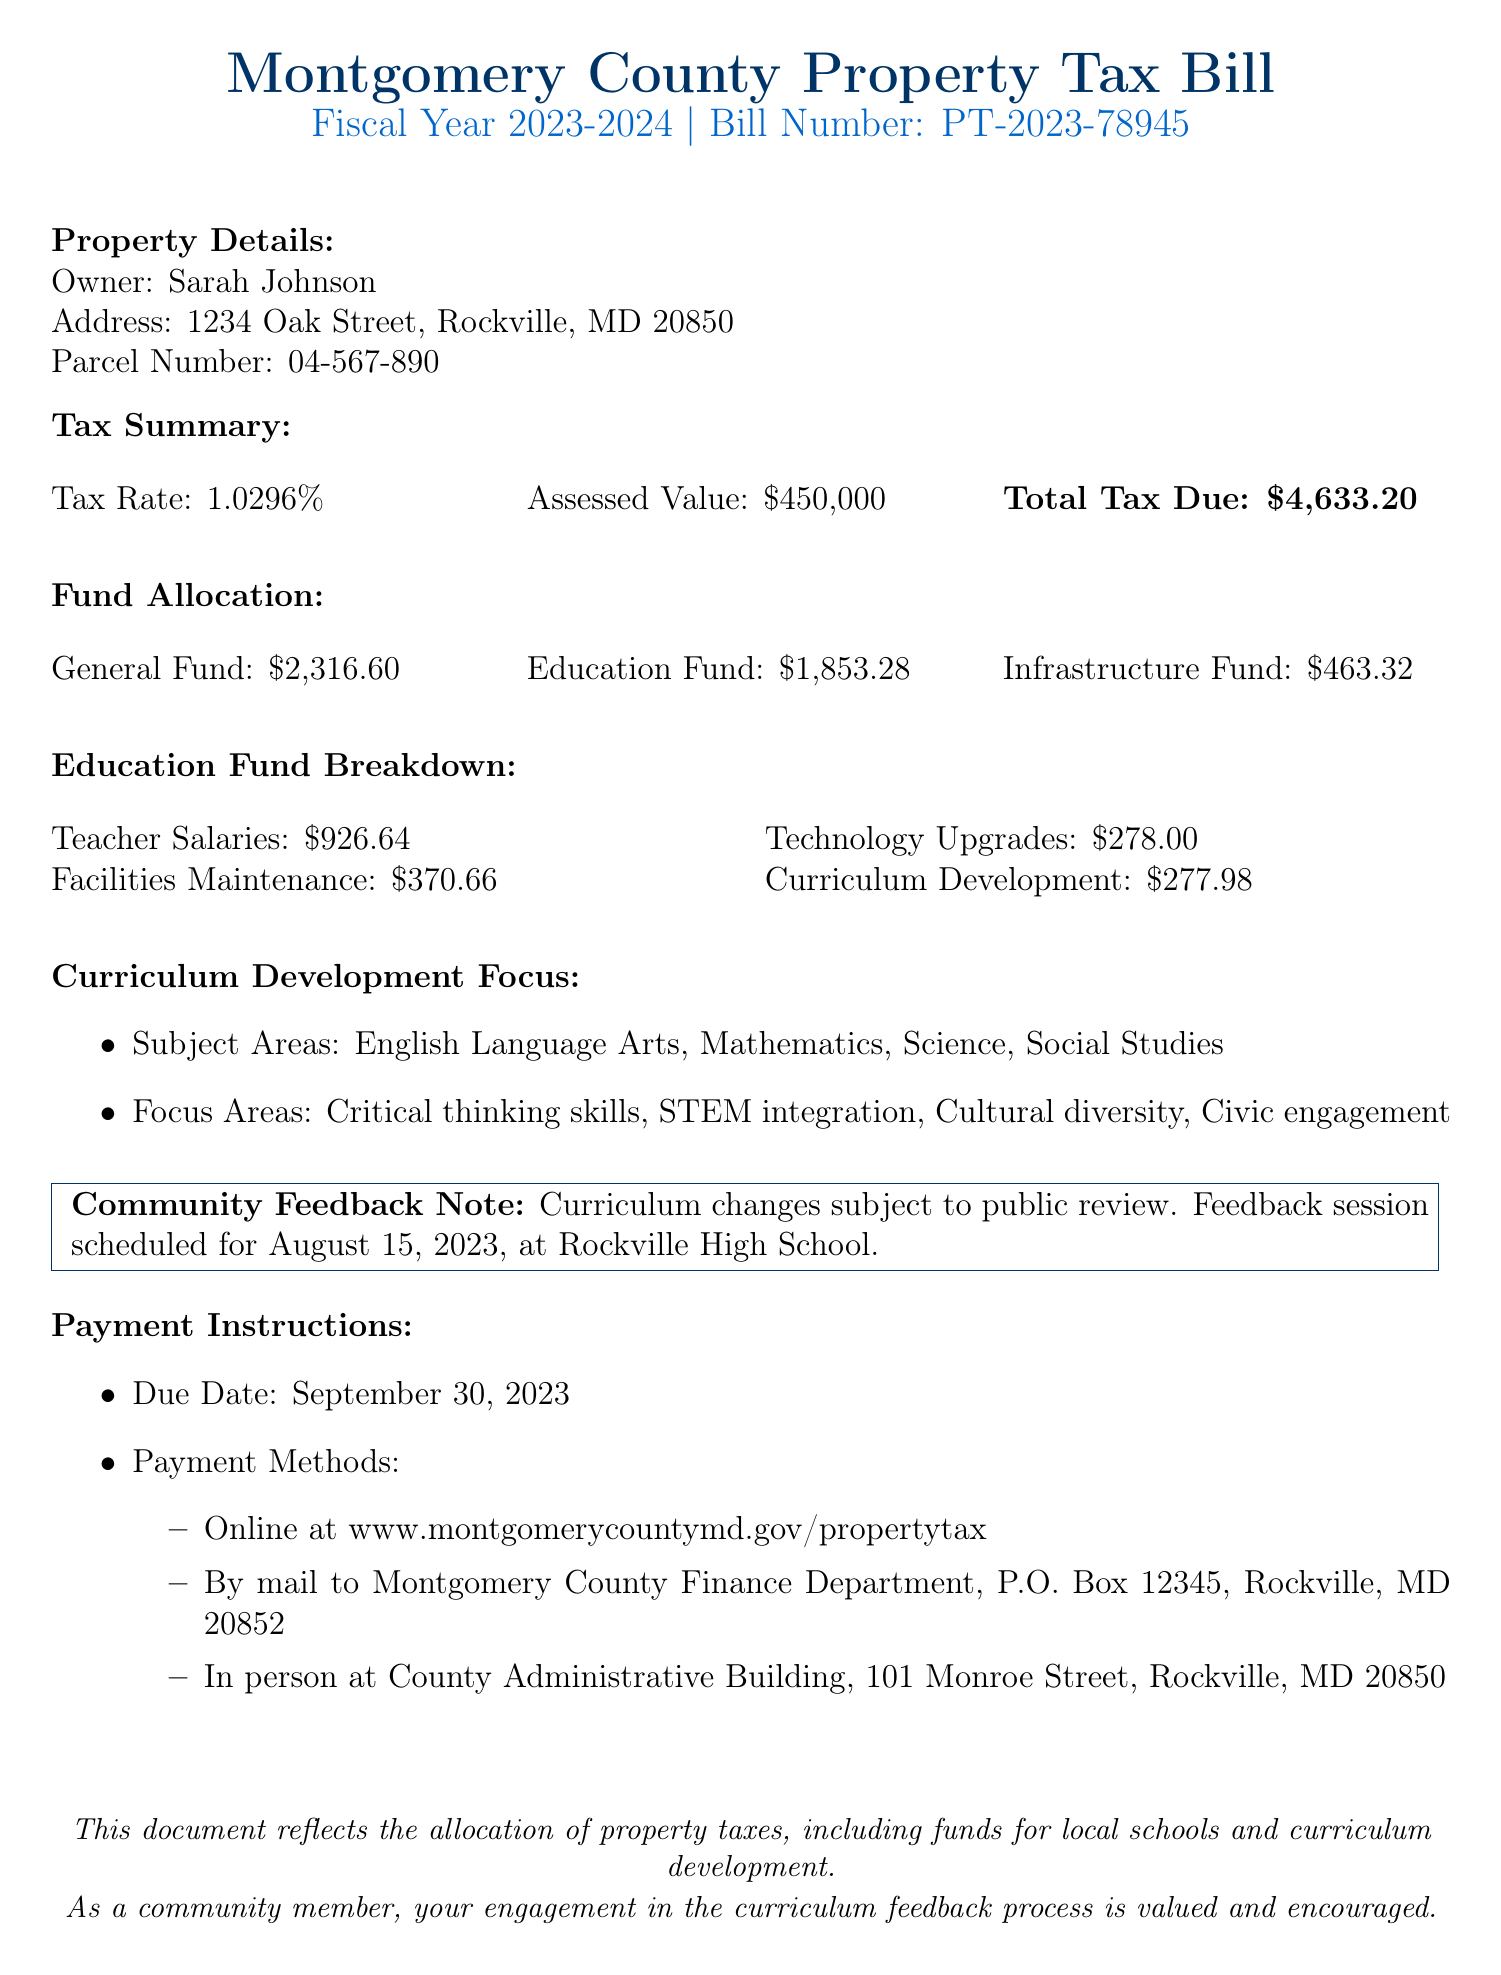what is the property tax rate? The property tax rate is directly stated in the document's tax summary section.
Answer: 1.0296% what is the total tax due? The total tax due is calculated and mentioned in the tax summary section.
Answer: $4,633.20 how much is allocated to the Education Fund? The amount allocated to the Education Fund is detailed in the fund allocation section of the document.
Answer: $1,853.28 what are the main focus areas for curriculum development? The focus areas for curriculum development are listed under the curriculum development focus section.
Answer: Critical thinking skills, STEM integration, Cultural diversity, Civic engagement when is the community feedback session scheduled? The date of the community feedback session is noted in the community feedback note section.
Answer: August 15, 2023 what is the breakdown of funds allocated for Teacher Salaries? The amount designated for Teacher Salaries is part of the education fund breakdown.
Answer: $926.64 what is the address for mailing payments? The address for mailing payments is provided in the payment instructions section.
Answer: Montgomery County Finance Department, P.O. Box 12345, Rockville, MD 20852 what portion of the education fund is allocated to curriculum development? The allocation for curriculum development is specified in the Education Fund Breakdown.
Answer: $277.98 how much is the allocation for technology upgrades? The specific funding amount for technology upgrades is mentioned in the education fund breakdown.
Answer: $278.00 